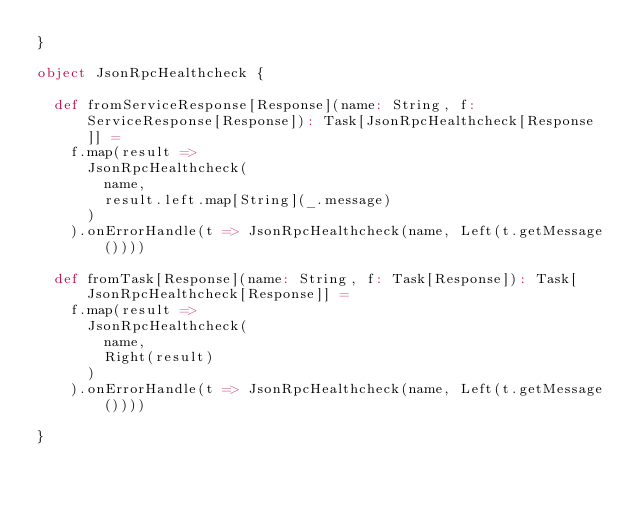Convert code to text. <code><loc_0><loc_0><loc_500><loc_500><_Scala_>}

object JsonRpcHealthcheck {

  def fromServiceResponse[Response](name: String, f: ServiceResponse[Response]): Task[JsonRpcHealthcheck[Response]] =
    f.map(result =>
      JsonRpcHealthcheck(
        name,
        result.left.map[String](_.message)
      )
    ).onErrorHandle(t => JsonRpcHealthcheck(name, Left(t.getMessage())))

  def fromTask[Response](name: String, f: Task[Response]): Task[JsonRpcHealthcheck[Response]] =
    f.map(result =>
      JsonRpcHealthcheck(
        name,
        Right(result)
      )
    ).onErrorHandle(t => JsonRpcHealthcheck(name, Left(t.getMessage())))

}
</code> 